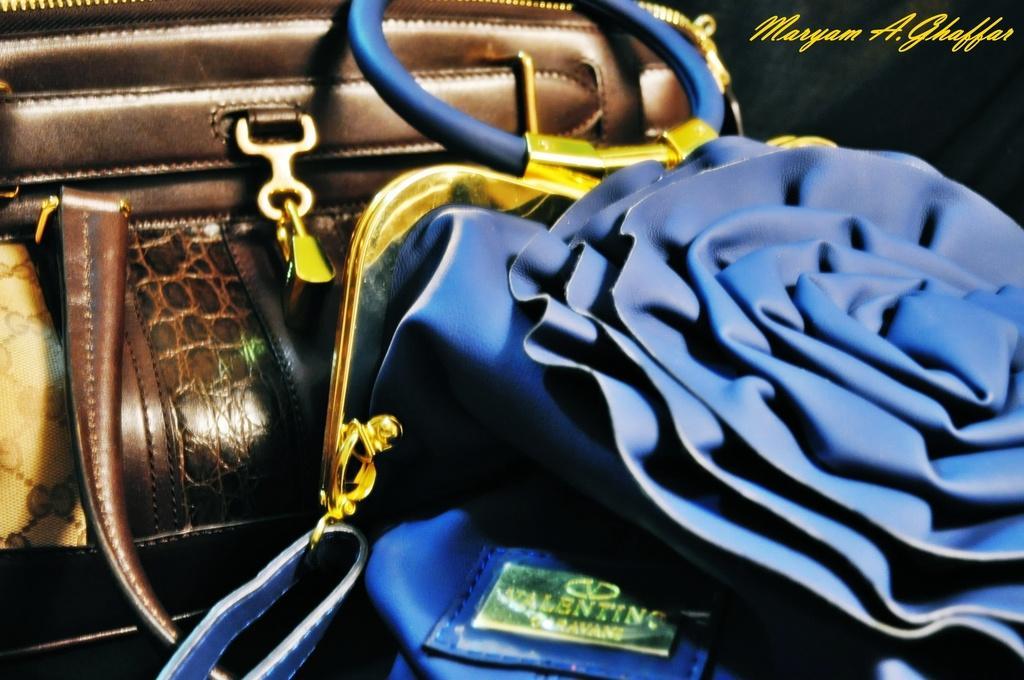Please provide a concise description of this image. In this picture we can see handbags. In the top right corner of the picture there is something written. 